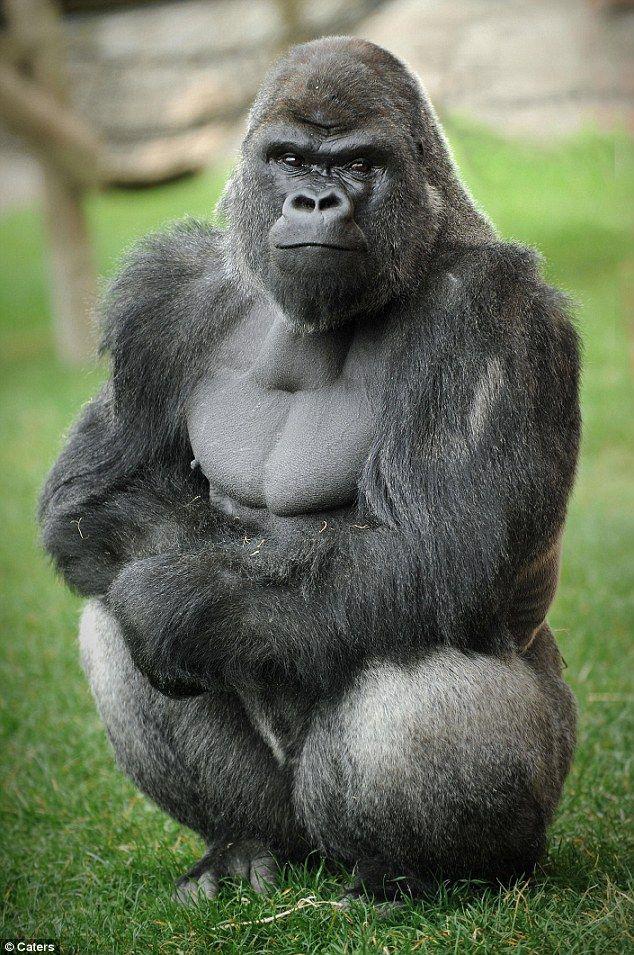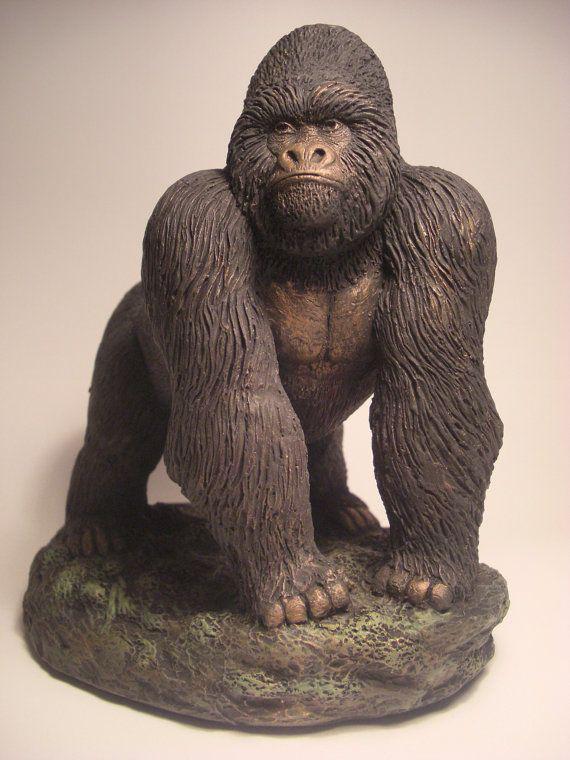The first image is the image on the left, the second image is the image on the right. For the images displayed, is the sentence "The combined images include a gorilla with crossed arms and a gorilla on all fours, and at least one gorilla depicted is a real animal." factually correct? Answer yes or no. Yes. The first image is the image on the left, the second image is the image on the right. For the images shown, is this caption "There are more than 2 gorillas depicted." true? Answer yes or no. No. 